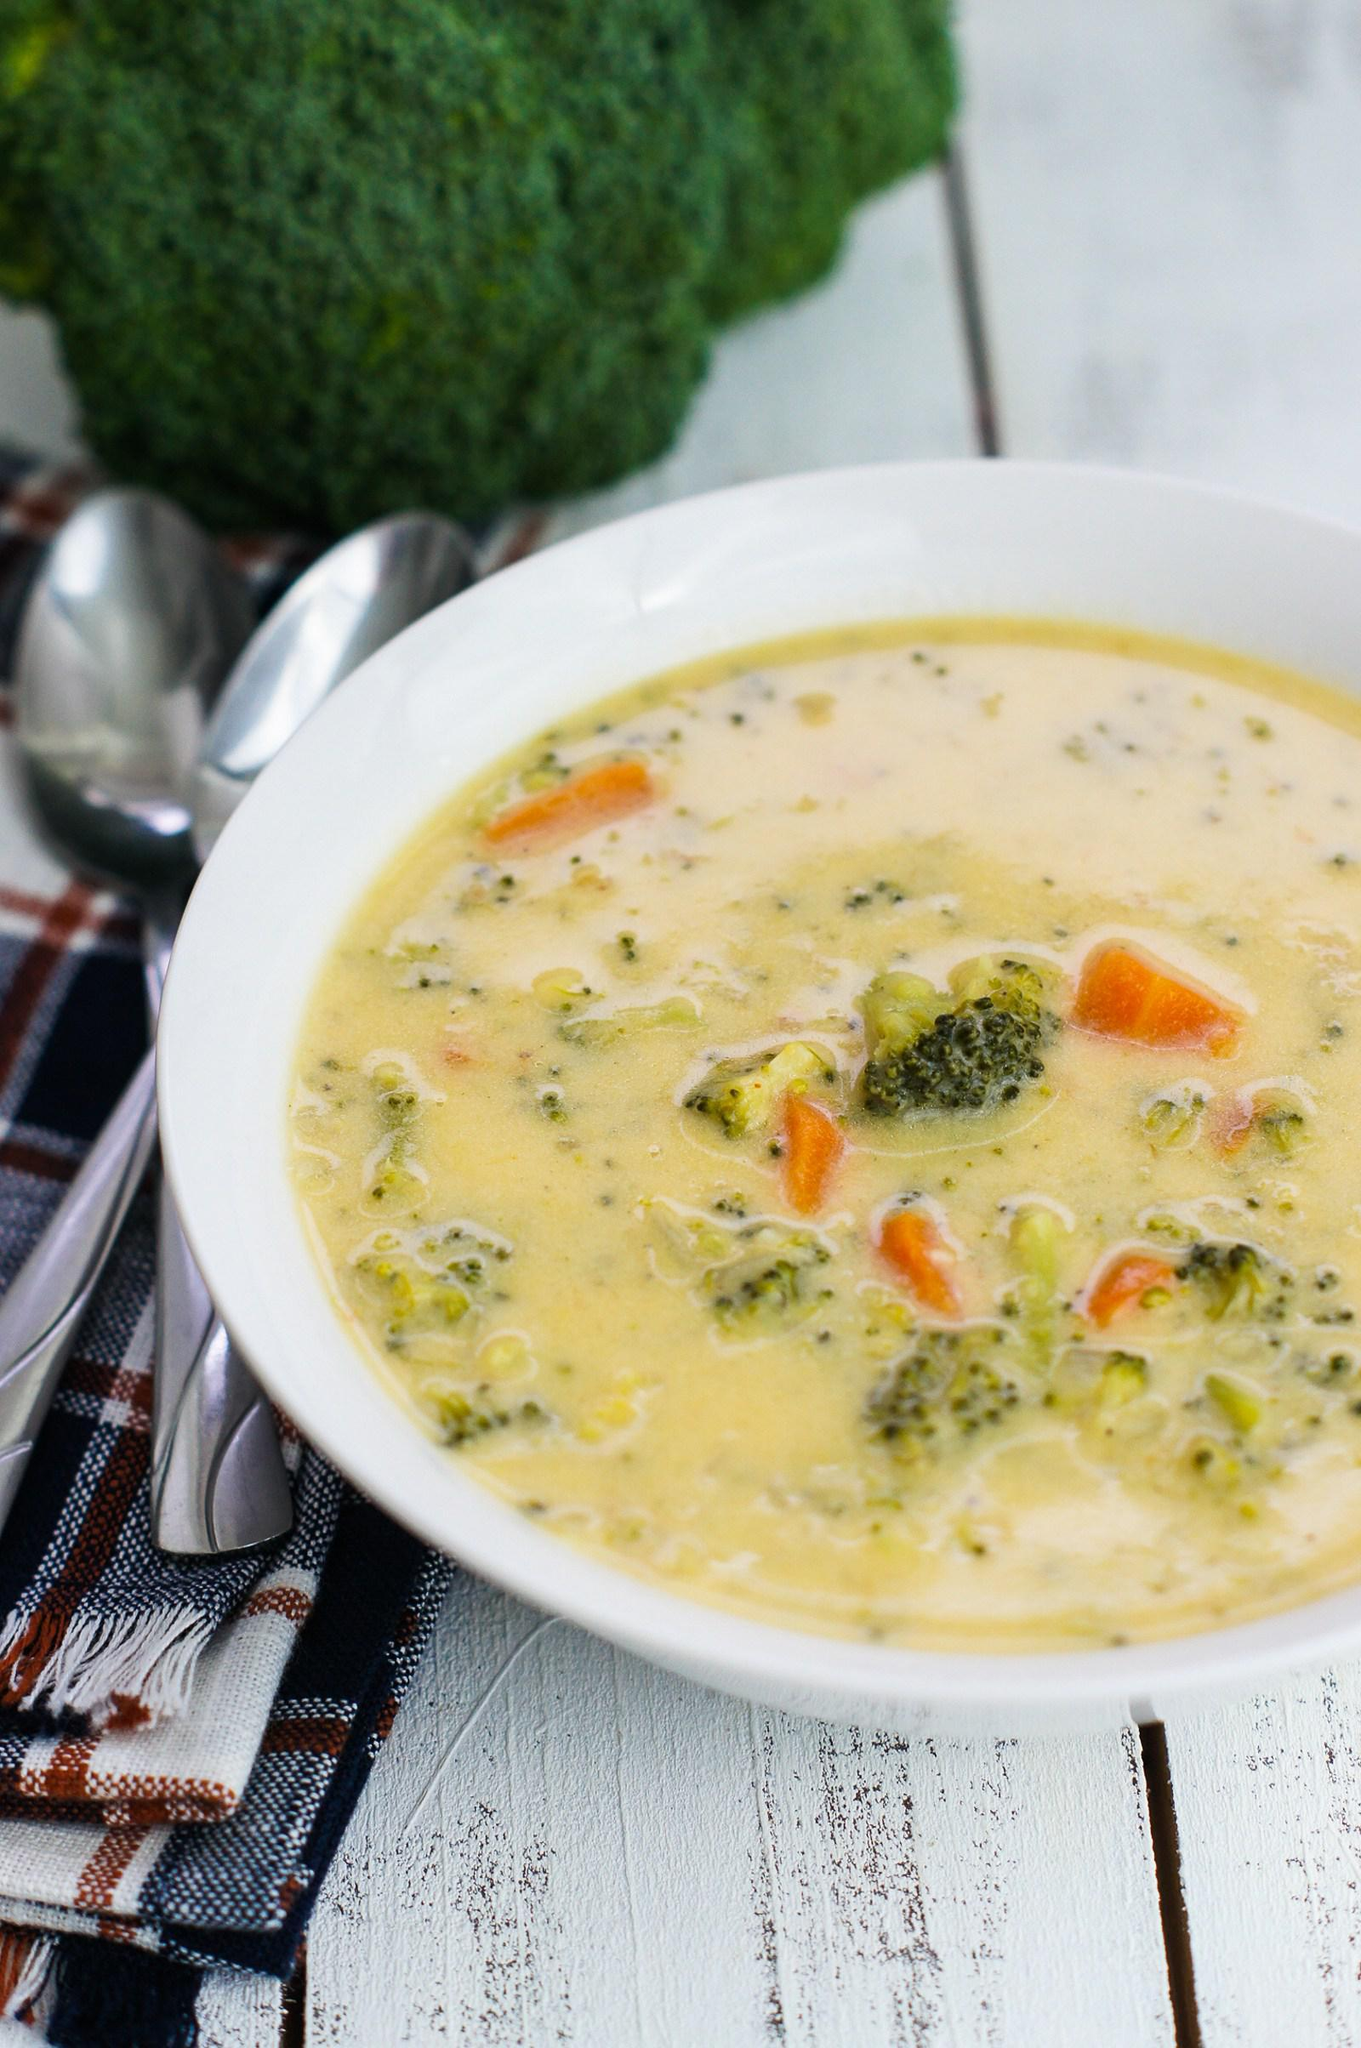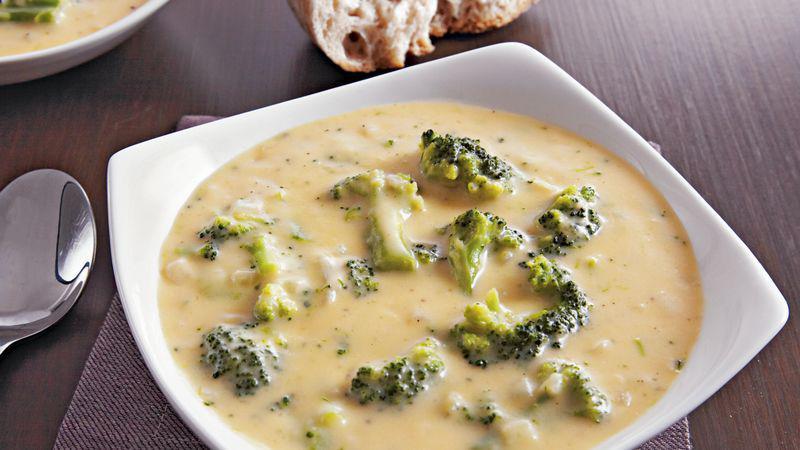The first image is the image on the left, the second image is the image on the right. Assess this claim about the two images: "There is a white plate beneath the soup in the image on the left.". Correct or not? Answer yes or no. No. 